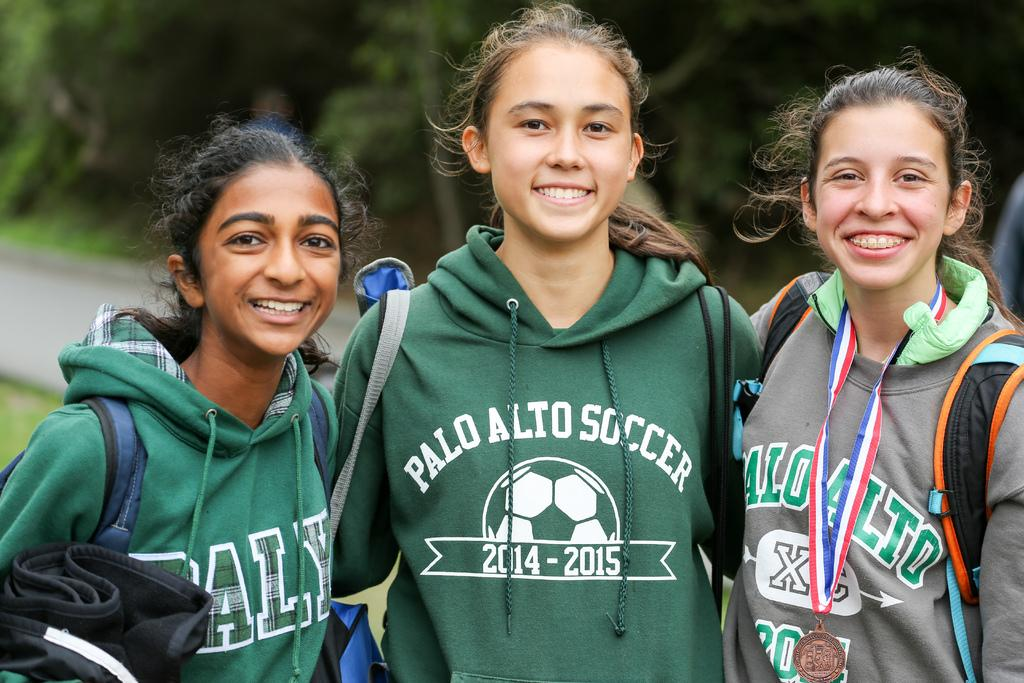How many women are in the image? There are three women in the image. What are the women doing in the image? The women are standing and smiling. What are the women holding in the image? The women are carrying bags. What can be seen in the background of the image? There are trees and grass in the background of the image. How would you describe the quality of the background in the image? The background is blurry. Is there any poison visible in the image? There is no poison present in the image. Can you see any grass slipping out of the women's bags in the image? There is no grass visible in the image, and the women are not shown holding any grass in their bags. 